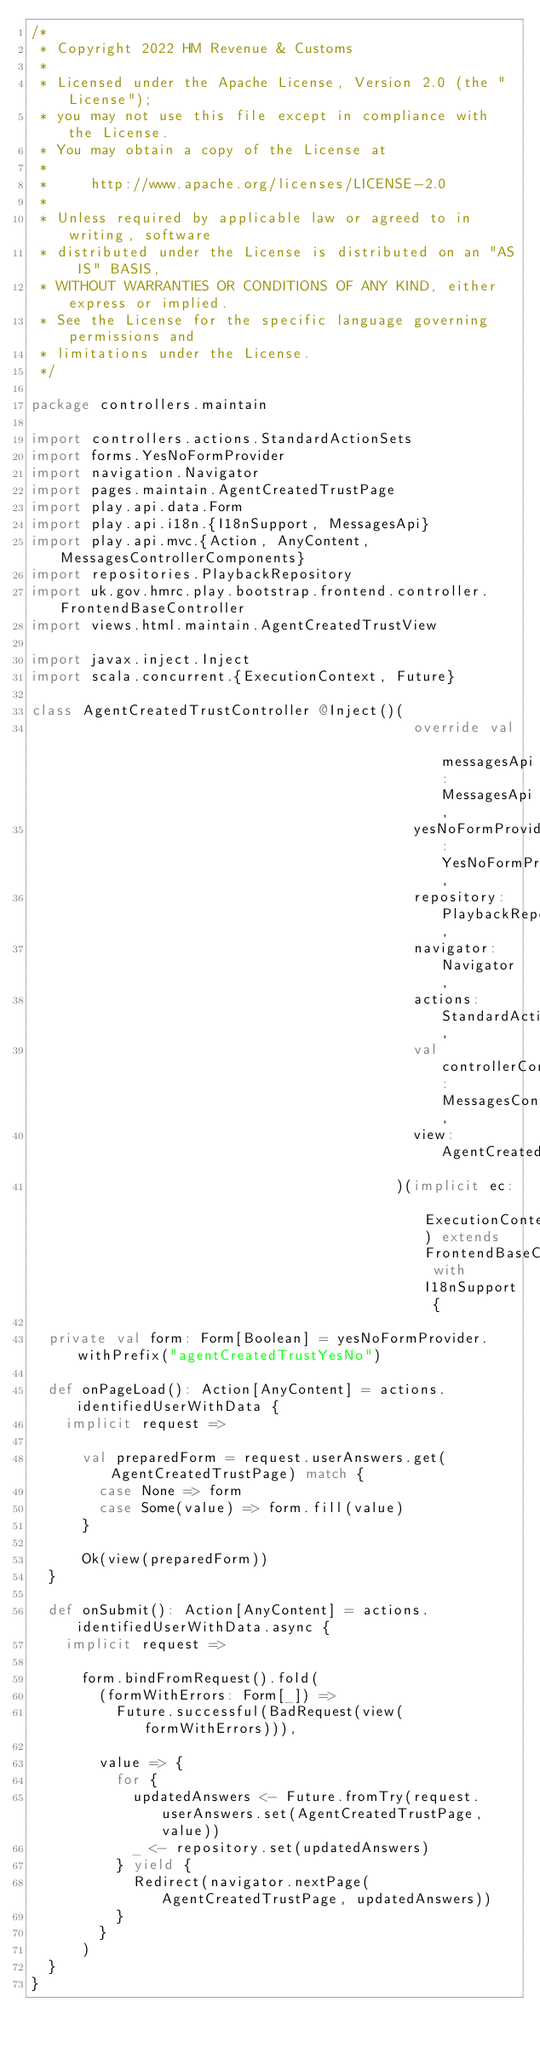Convert code to text. <code><loc_0><loc_0><loc_500><loc_500><_Scala_>/*
 * Copyright 2022 HM Revenue & Customs
 *
 * Licensed under the Apache License, Version 2.0 (the "License");
 * you may not use this file except in compliance with the License.
 * You may obtain a copy of the License at
 *
 *     http://www.apache.org/licenses/LICENSE-2.0
 *
 * Unless required by applicable law or agreed to in writing, software
 * distributed under the License is distributed on an "AS IS" BASIS,
 * WITHOUT WARRANTIES OR CONDITIONS OF ANY KIND, either express or implied.
 * See the License for the specific language governing permissions and
 * limitations under the License.
 */

package controllers.maintain

import controllers.actions.StandardActionSets
import forms.YesNoFormProvider
import navigation.Navigator
import pages.maintain.AgentCreatedTrustPage
import play.api.data.Form
import play.api.i18n.{I18nSupport, MessagesApi}
import play.api.mvc.{Action, AnyContent, MessagesControllerComponents}
import repositories.PlaybackRepository
import uk.gov.hmrc.play.bootstrap.frontend.controller.FrontendBaseController
import views.html.maintain.AgentCreatedTrustView

import javax.inject.Inject
import scala.concurrent.{ExecutionContext, Future}

class AgentCreatedTrustController @Inject()(
                                             override val messagesApi: MessagesApi,
                                             yesNoFormProvider: YesNoFormProvider,
                                             repository: PlaybackRepository,
                                             navigator: Navigator,
                                             actions: StandardActionSets,
                                             val controllerComponents: MessagesControllerComponents,
                                             view: AgentCreatedTrustView
                                           )(implicit ec: ExecutionContext) extends FrontendBaseController with I18nSupport {

  private val form: Form[Boolean] = yesNoFormProvider.withPrefix("agentCreatedTrustYesNo")

  def onPageLoad(): Action[AnyContent] = actions.identifiedUserWithData {
    implicit request =>

      val preparedForm = request.userAnswers.get(AgentCreatedTrustPage) match {
        case None => form
        case Some(value) => form.fill(value)
      }

      Ok(view(preparedForm))
  }

  def onSubmit(): Action[AnyContent] = actions.identifiedUserWithData.async {
    implicit request =>

      form.bindFromRequest().fold(
        (formWithErrors: Form[_]) =>
          Future.successful(BadRequest(view(formWithErrors))),

        value => {
          for {
            updatedAnswers <- Future.fromTry(request.userAnswers.set(AgentCreatedTrustPage, value))
            _ <- repository.set(updatedAnswers)
          } yield {
            Redirect(navigator.nextPage(AgentCreatedTrustPage, updatedAnswers))
          }
        }
      )
  }
}
</code> 